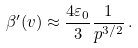Convert formula to latex. <formula><loc_0><loc_0><loc_500><loc_500>\beta ^ { \prime } ( v ) \approx \frac { 4 \varepsilon _ { 0 } } { 3 } \frac { 1 } { p ^ { 3 / 2 } } \, .</formula> 